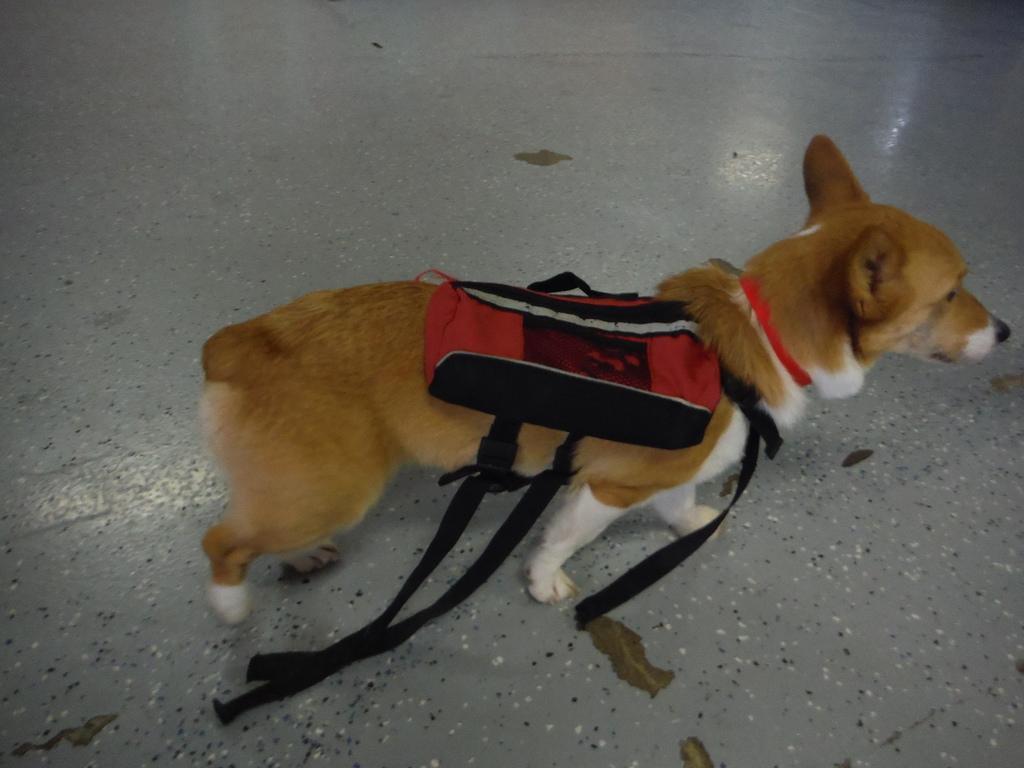Could you give a brief overview of what you see in this image? In this image I can see the dog in brown and white color and I can see the red and black color body belt on the dog. 